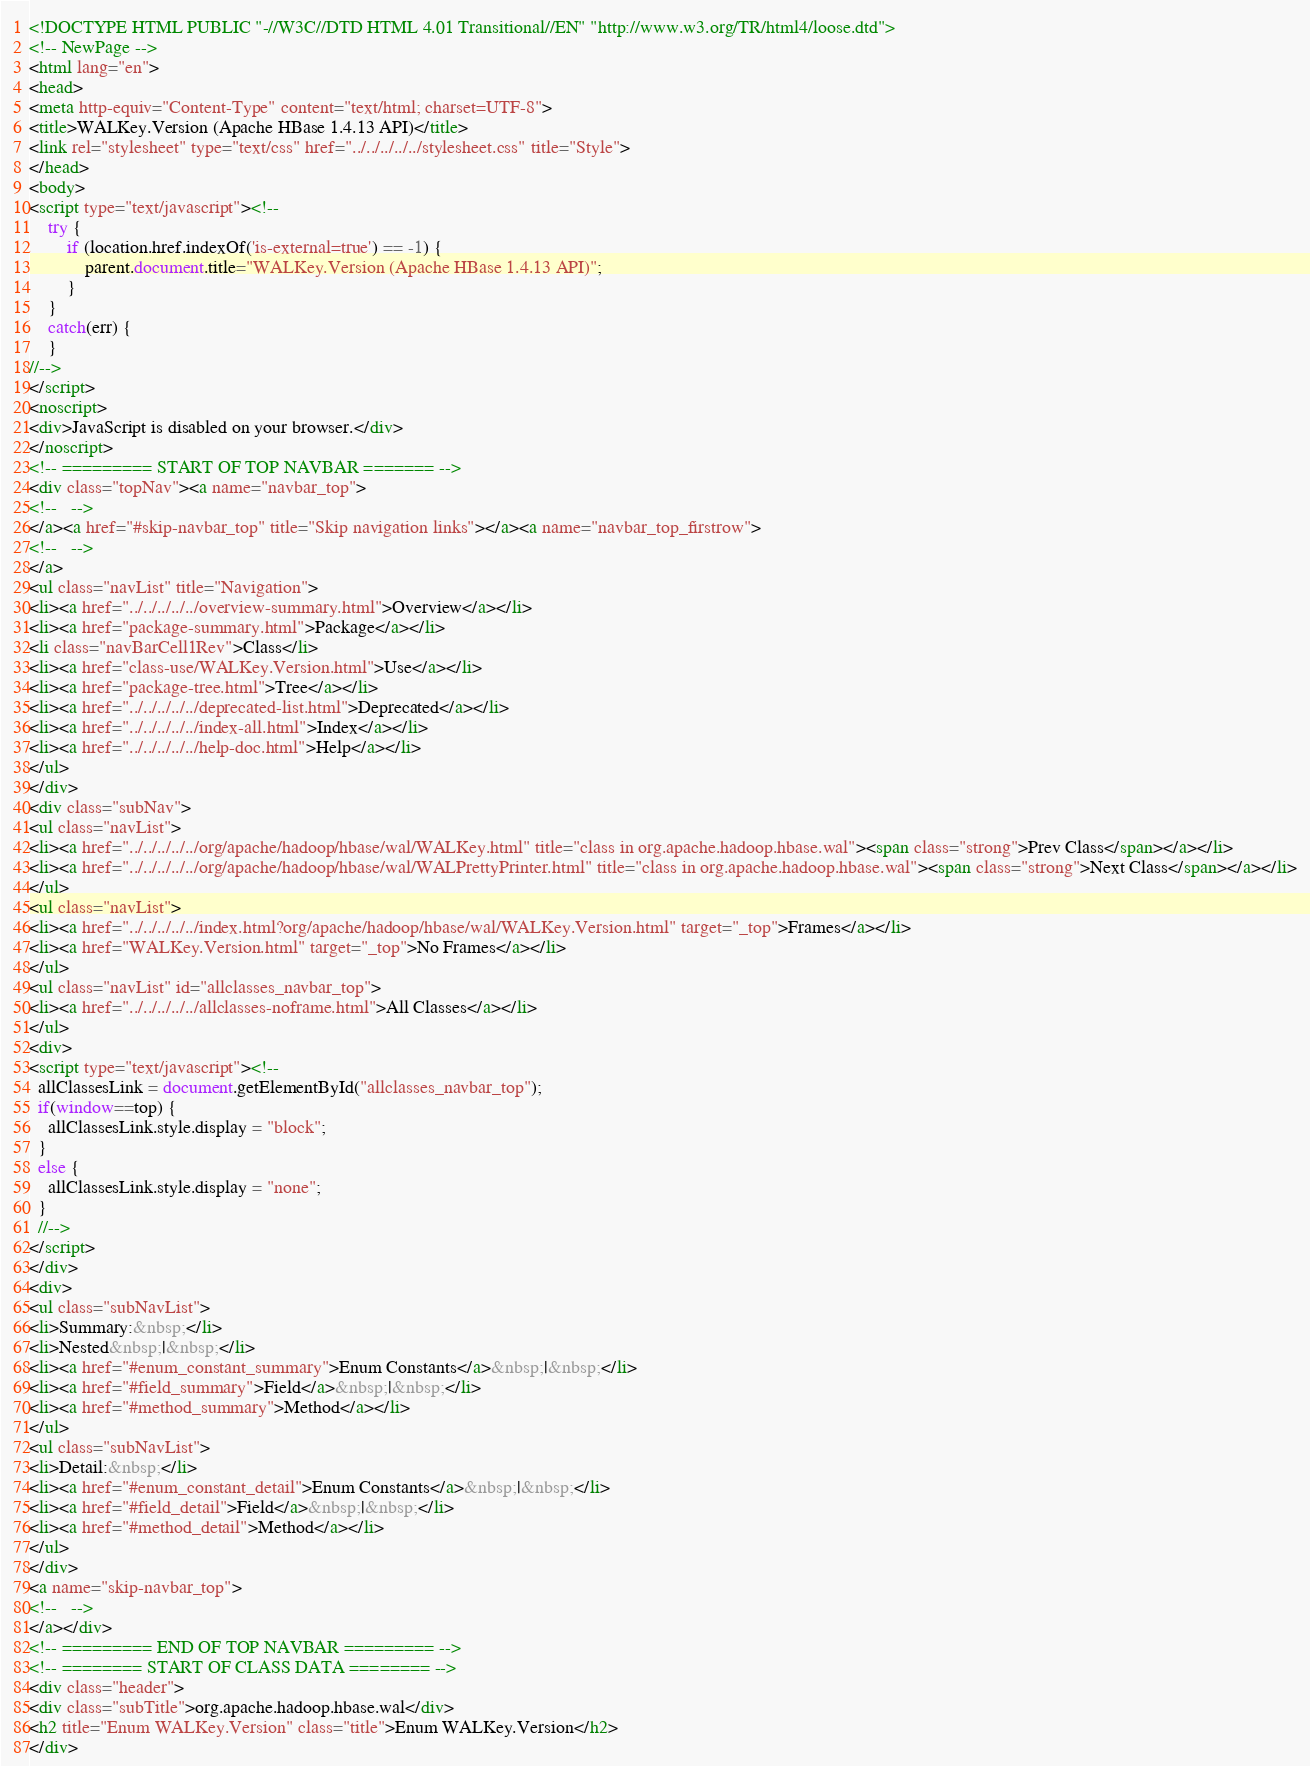Convert code to text. <code><loc_0><loc_0><loc_500><loc_500><_HTML_><!DOCTYPE HTML PUBLIC "-//W3C//DTD HTML 4.01 Transitional//EN" "http://www.w3.org/TR/html4/loose.dtd">
<!-- NewPage -->
<html lang="en">
<head>
<meta http-equiv="Content-Type" content="text/html; charset=UTF-8">
<title>WALKey.Version (Apache HBase 1.4.13 API)</title>
<link rel="stylesheet" type="text/css" href="../../../../../stylesheet.css" title="Style">
</head>
<body>
<script type="text/javascript"><!--
    try {
        if (location.href.indexOf('is-external=true') == -1) {
            parent.document.title="WALKey.Version (Apache HBase 1.4.13 API)";
        }
    }
    catch(err) {
    }
//-->
</script>
<noscript>
<div>JavaScript is disabled on your browser.</div>
</noscript>
<!-- ========= START OF TOP NAVBAR ======= -->
<div class="topNav"><a name="navbar_top">
<!--   -->
</a><a href="#skip-navbar_top" title="Skip navigation links"></a><a name="navbar_top_firstrow">
<!--   -->
</a>
<ul class="navList" title="Navigation">
<li><a href="../../../../../overview-summary.html">Overview</a></li>
<li><a href="package-summary.html">Package</a></li>
<li class="navBarCell1Rev">Class</li>
<li><a href="class-use/WALKey.Version.html">Use</a></li>
<li><a href="package-tree.html">Tree</a></li>
<li><a href="../../../../../deprecated-list.html">Deprecated</a></li>
<li><a href="../../../../../index-all.html">Index</a></li>
<li><a href="../../../../../help-doc.html">Help</a></li>
</ul>
</div>
<div class="subNav">
<ul class="navList">
<li><a href="../../../../../org/apache/hadoop/hbase/wal/WALKey.html" title="class in org.apache.hadoop.hbase.wal"><span class="strong">Prev Class</span></a></li>
<li><a href="../../../../../org/apache/hadoop/hbase/wal/WALPrettyPrinter.html" title="class in org.apache.hadoop.hbase.wal"><span class="strong">Next Class</span></a></li>
</ul>
<ul class="navList">
<li><a href="../../../../../index.html?org/apache/hadoop/hbase/wal/WALKey.Version.html" target="_top">Frames</a></li>
<li><a href="WALKey.Version.html" target="_top">No Frames</a></li>
</ul>
<ul class="navList" id="allclasses_navbar_top">
<li><a href="../../../../../allclasses-noframe.html">All Classes</a></li>
</ul>
<div>
<script type="text/javascript"><!--
  allClassesLink = document.getElementById("allclasses_navbar_top");
  if(window==top) {
    allClassesLink.style.display = "block";
  }
  else {
    allClassesLink.style.display = "none";
  }
  //-->
</script>
</div>
<div>
<ul class="subNavList">
<li>Summary:&nbsp;</li>
<li>Nested&nbsp;|&nbsp;</li>
<li><a href="#enum_constant_summary">Enum Constants</a>&nbsp;|&nbsp;</li>
<li><a href="#field_summary">Field</a>&nbsp;|&nbsp;</li>
<li><a href="#method_summary">Method</a></li>
</ul>
<ul class="subNavList">
<li>Detail:&nbsp;</li>
<li><a href="#enum_constant_detail">Enum Constants</a>&nbsp;|&nbsp;</li>
<li><a href="#field_detail">Field</a>&nbsp;|&nbsp;</li>
<li><a href="#method_detail">Method</a></li>
</ul>
</div>
<a name="skip-navbar_top">
<!--   -->
</a></div>
<!-- ========= END OF TOP NAVBAR ========= -->
<!-- ======== START OF CLASS DATA ======== -->
<div class="header">
<div class="subTitle">org.apache.hadoop.hbase.wal</div>
<h2 title="Enum WALKey.Version" class="title">Enum WALKey.Version</h2>
</div></code> 